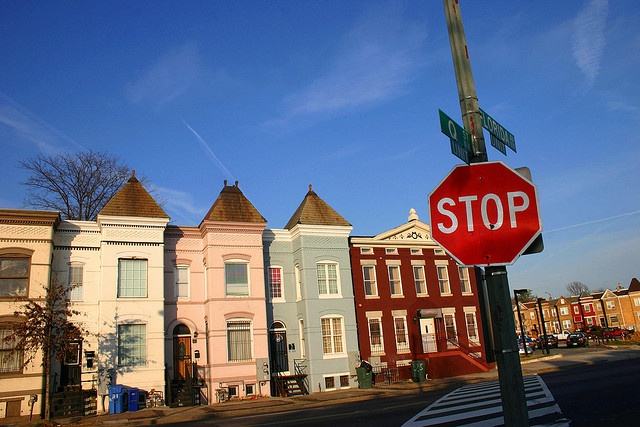Describe the objects in this image and their specific colors. I can see stop sign in darkblue, maroon, darkgray, and brown tones, car in darkblue, black, maroon, gray, and navy tones, car in darkblue, black, maroon, and brown tones, car in darkblue, black, maroon, gray, and blue tones, and car in darkblue, black, gray, navy, and blue tones in this image. 